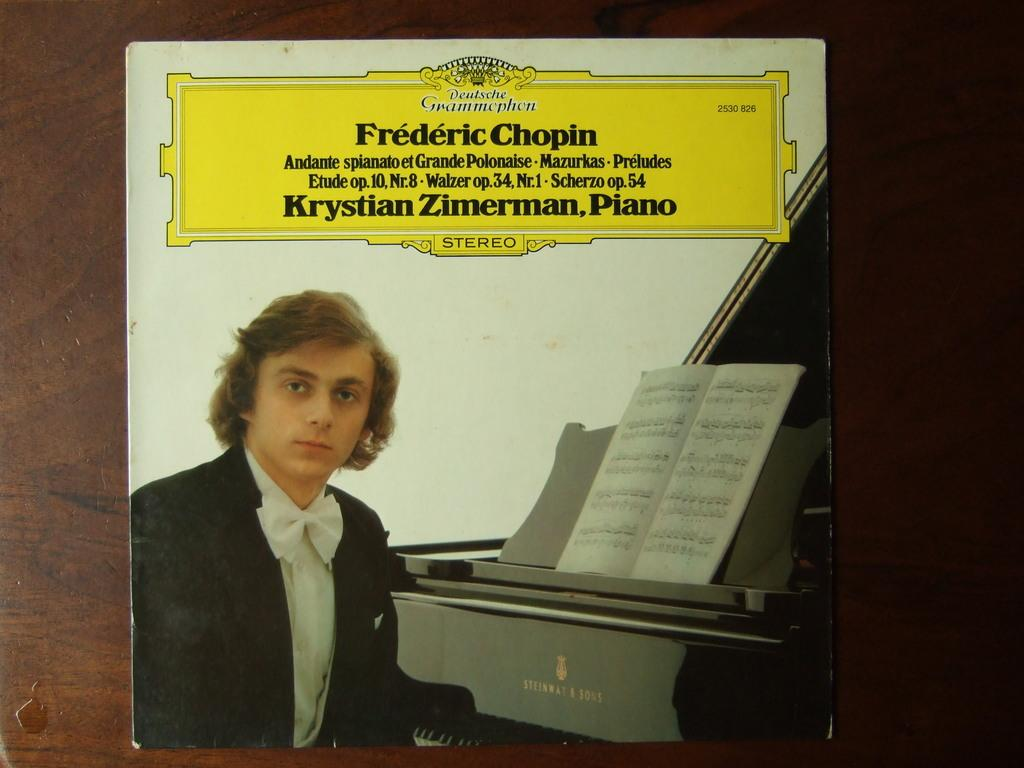Provide a one-sentence caption for the provided image. Frederic Chopin Krstian Zimerman Piano record with a guy in front of a piano. 